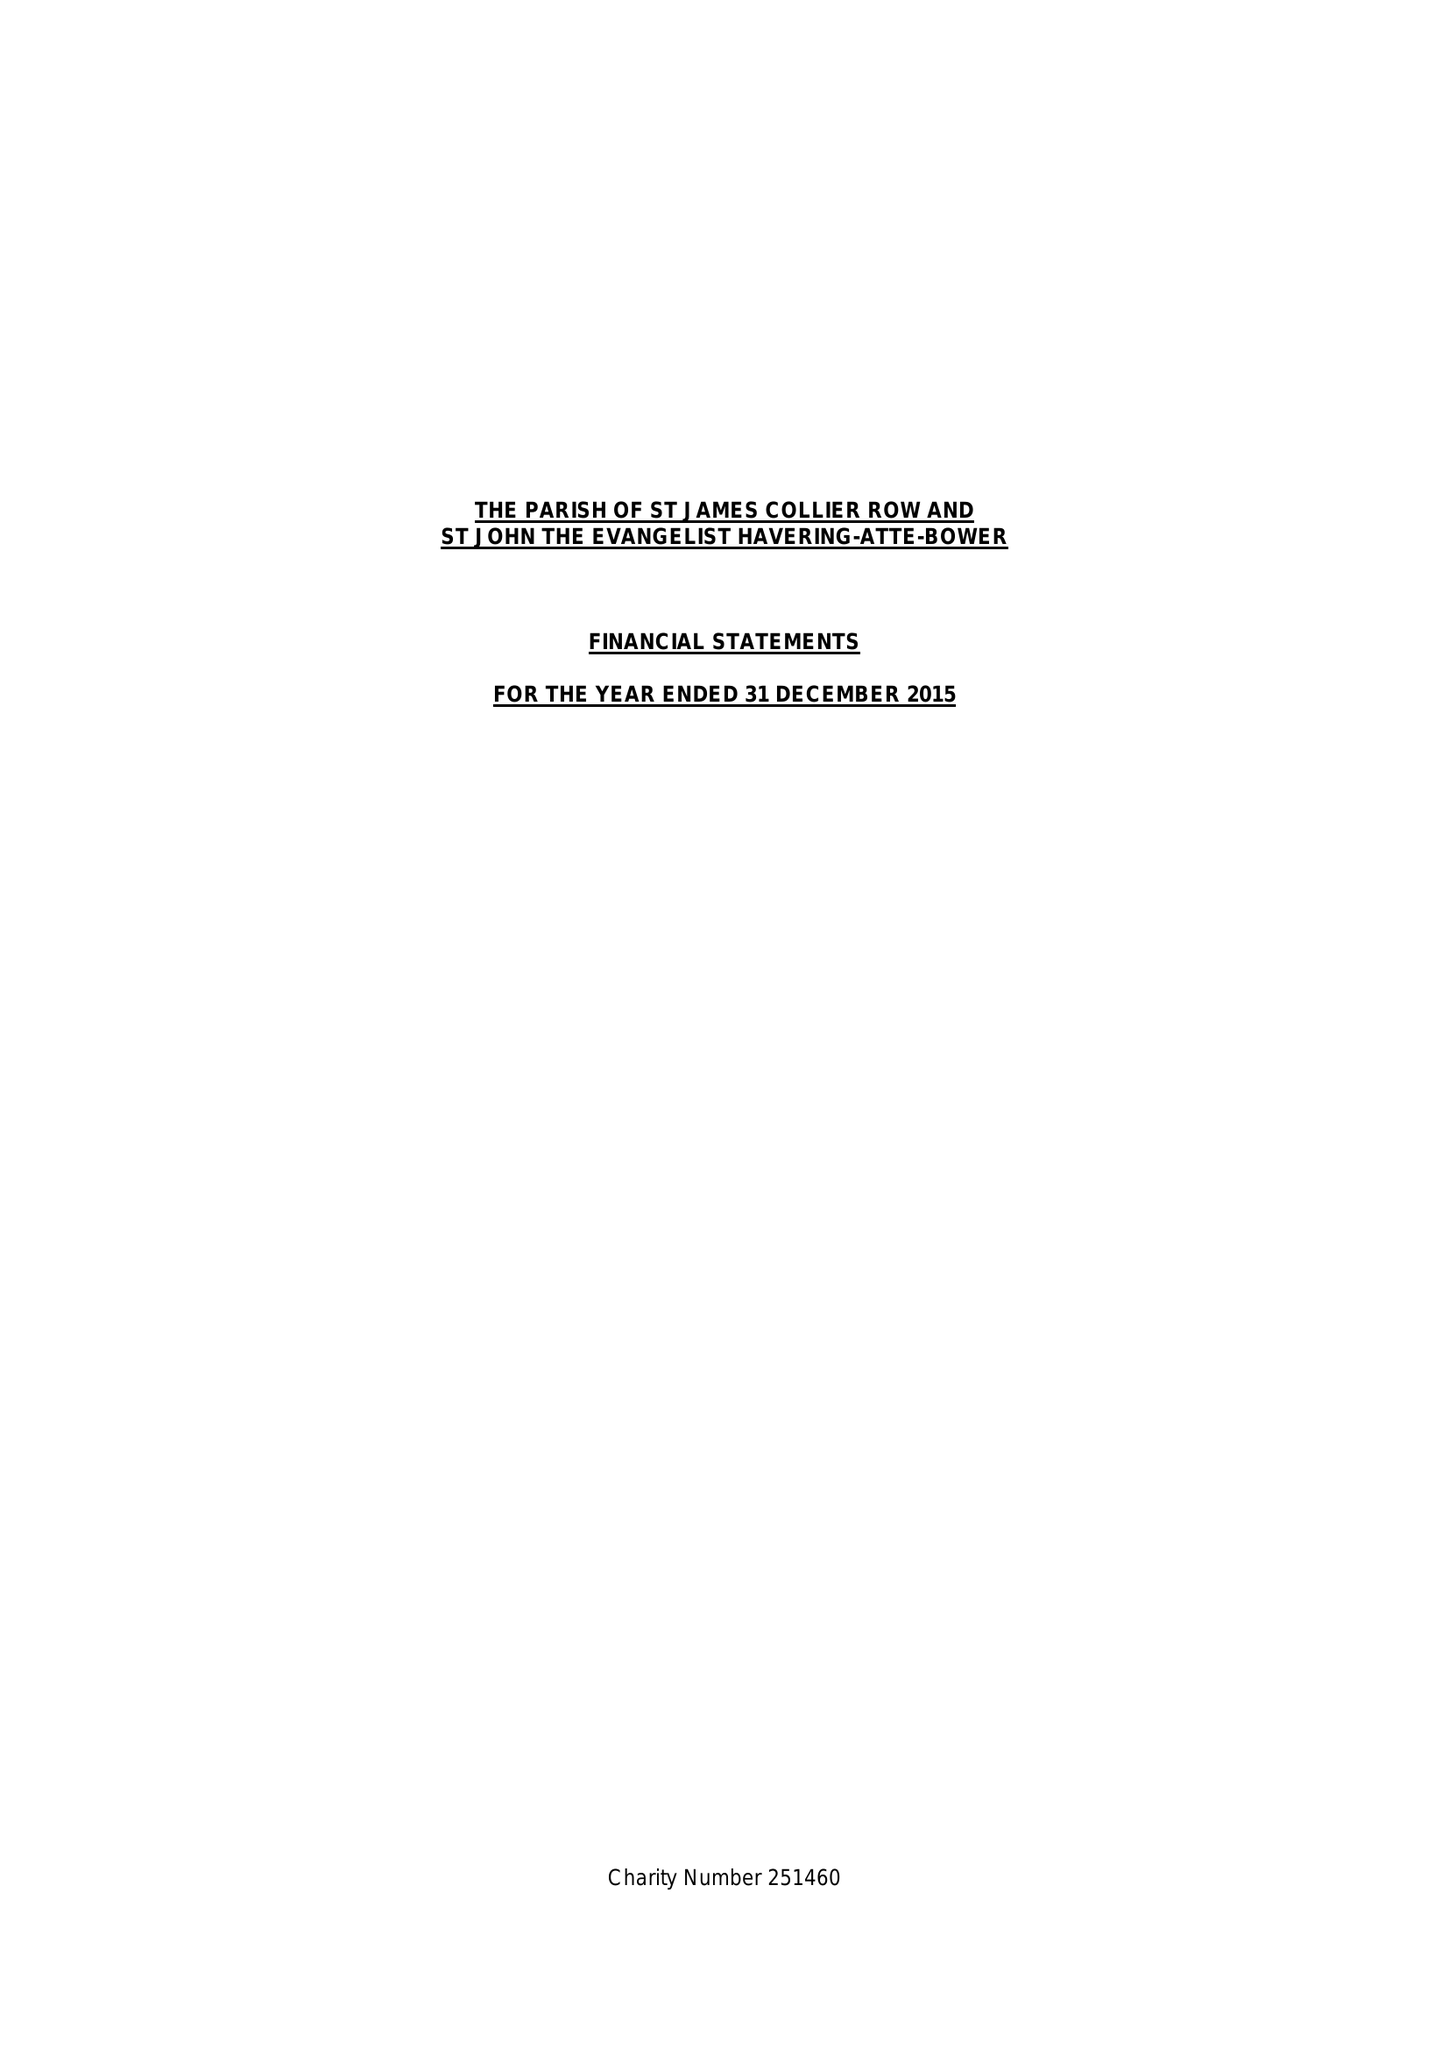What is the value for the spending_annually_in_british_pounds?
Answer the question using a single word or phrase. 140725.00 